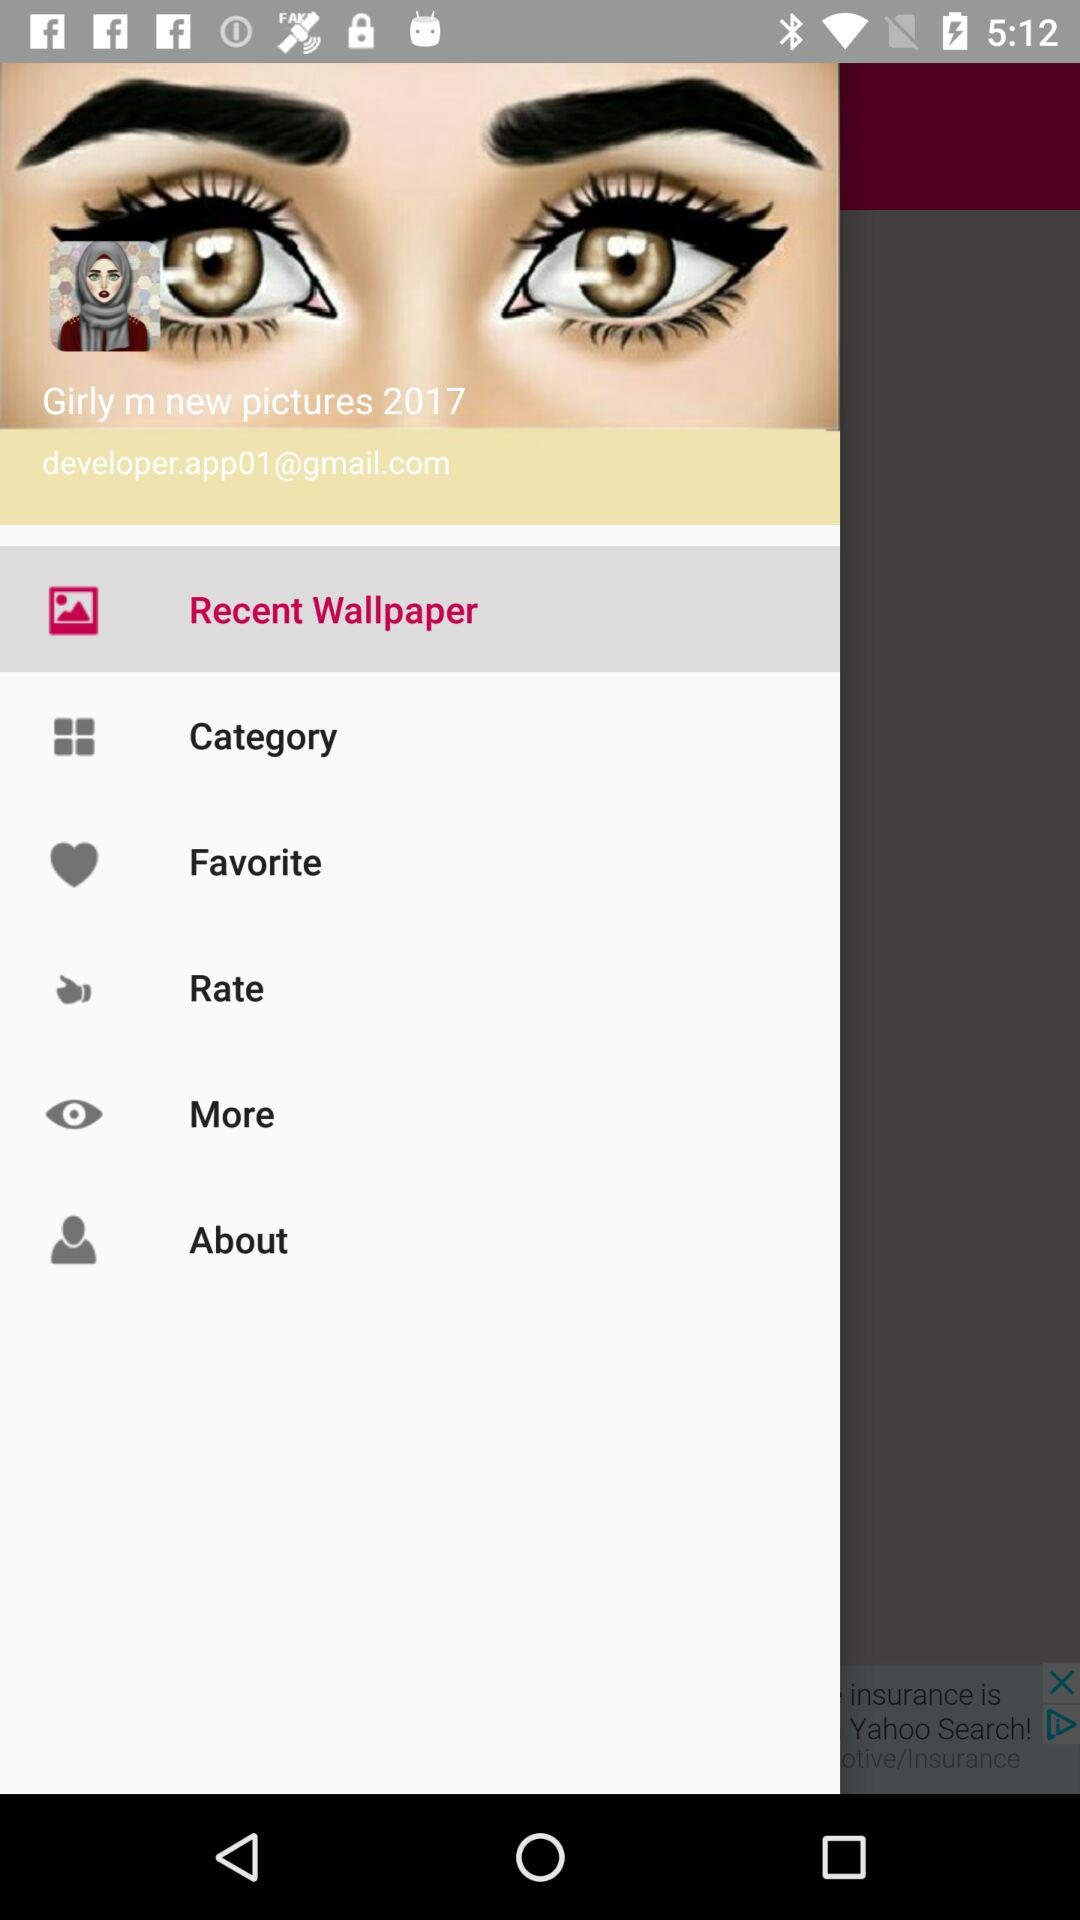What is the given email address? The given email address is developer.app01@gmail.com. 